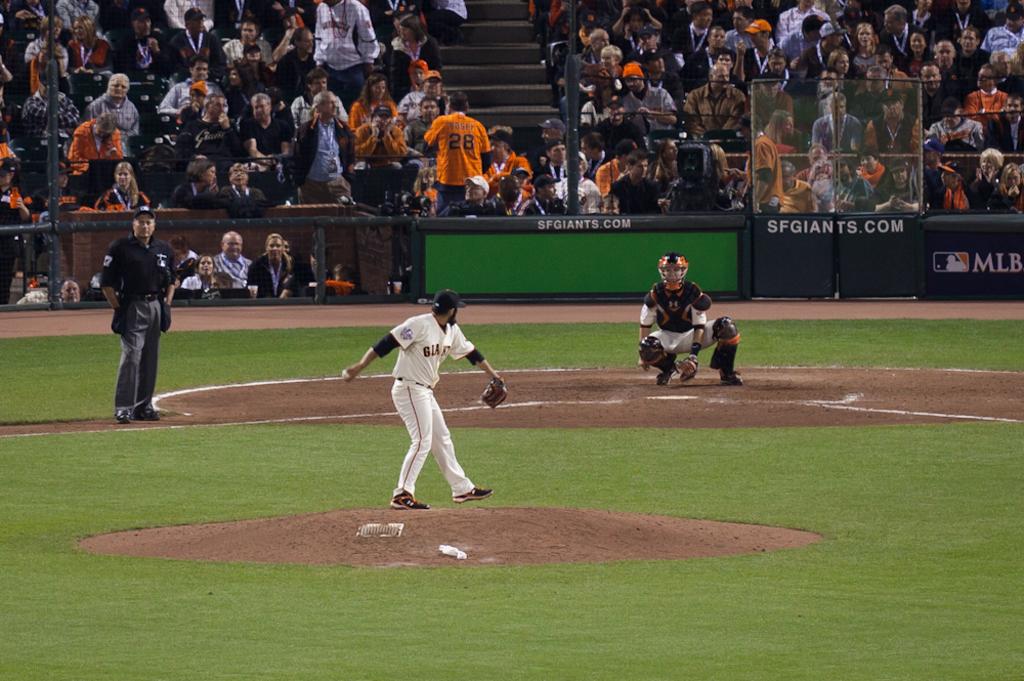What website is on the wall?
Your answer should be very brief. Sfgiants.com. 